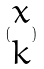<formula> <loc_0><loc_0><loc_500><loc_500>( \begin{matrix} x \\ k \end{matrix} )</formula> 